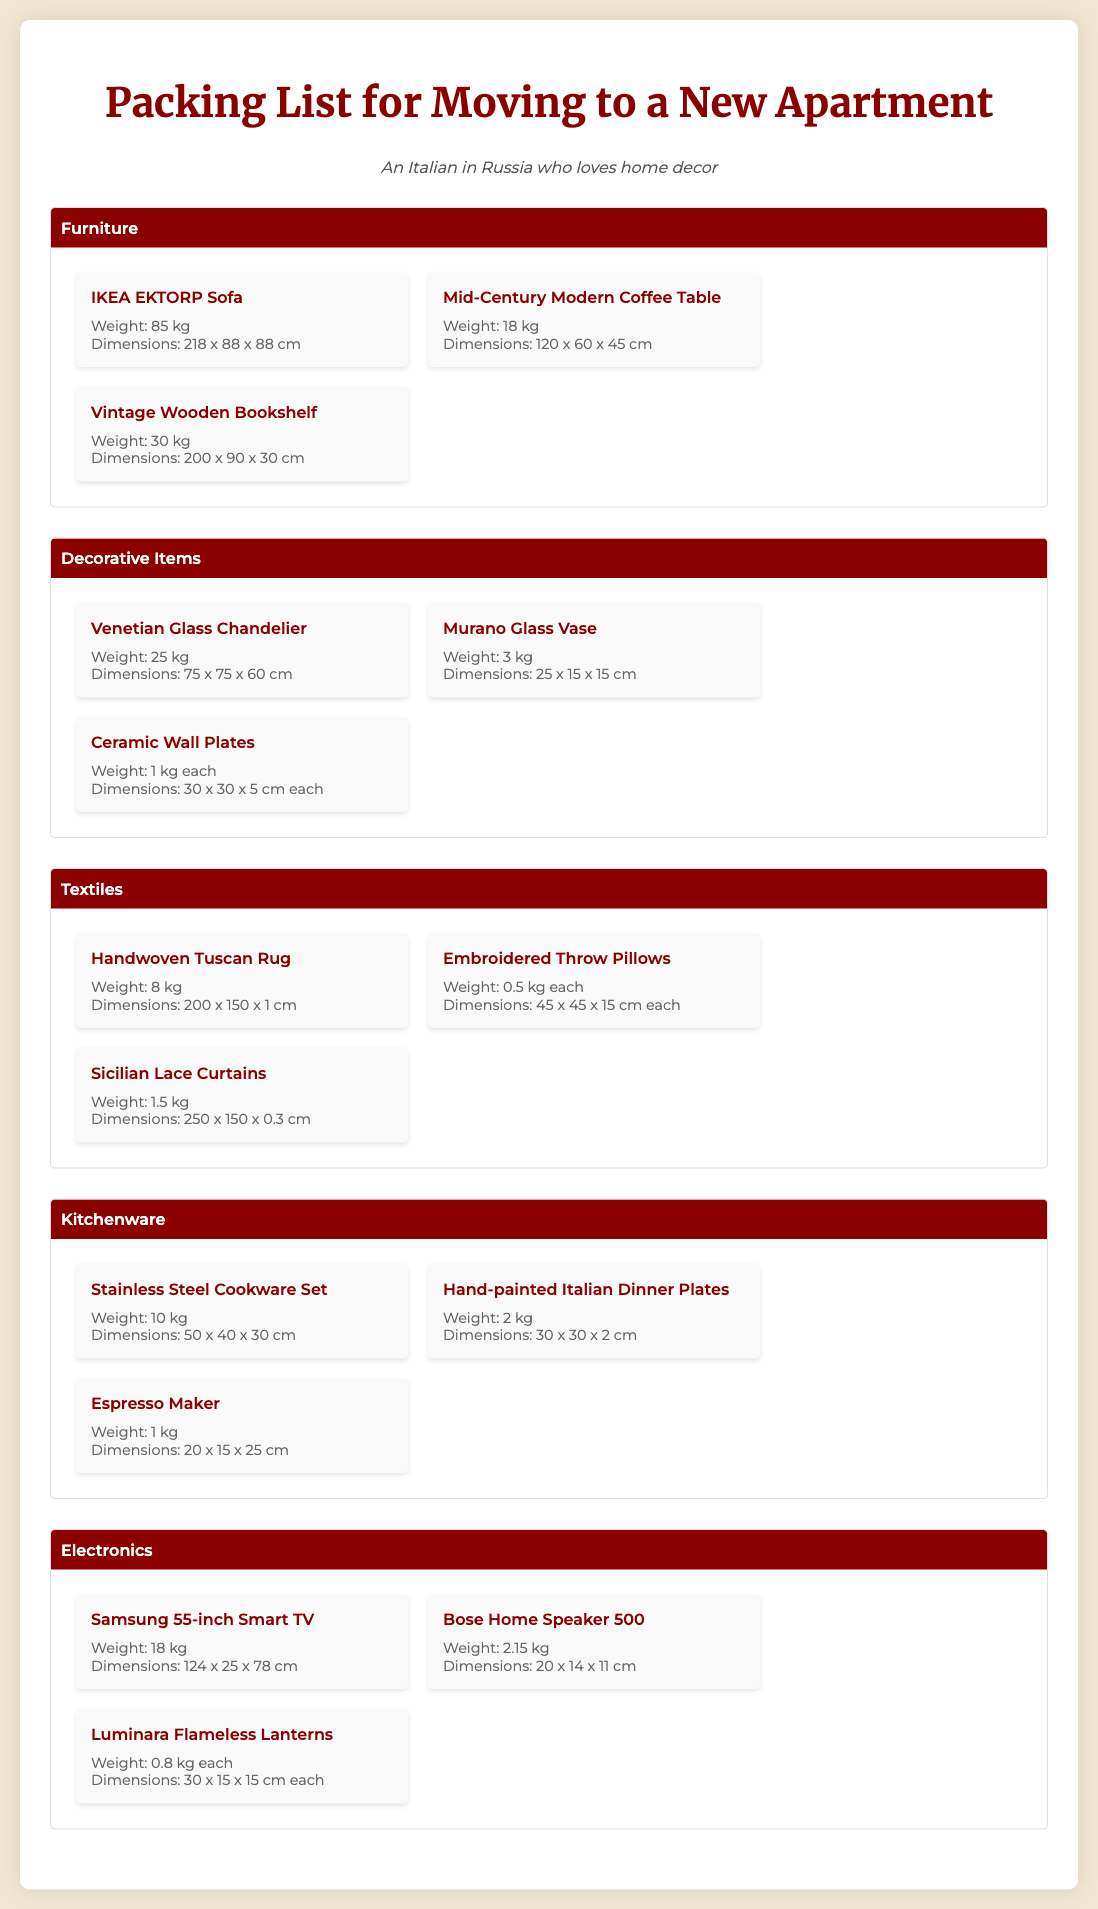What is the weight of the IKEA EKTORP Sofa? The weight of the IKEA EKTORP Sofa is specifically mentioned in the document as 85 kg.
Answer: 85 kg What are the dimensions of the Venetian Glass Chandelier? The dimensions of the Venetian Glass Chandelier are stated as 75 x 75 x 60 cm in the document.
Answer: 75 x 75 x 60 cm How many Decorative Items are listed? The document lists three items under Decorative Items: Venetian Glass Chandelier, Murano Glass Vase, and Ceramic Wall Plates.
Answer: Three Which furniture item has the highest weight? The item with the highest weight among the furniture listed is the IKEA EKTORP Sofa with a weight of 85 kg.
Answer: IKEA EKTORP Sofa What is the combined weight of the Textile items? The total weight of Textile items can be calculated as 8 kg (rug) + 0.5 kg (each pillow, two pillows) + 1.5 kg (curtains) = 10.5 kg.
Answer: 10.5 kg What type of cookware is included in the Kitchenware category? The Kitchenware category includes a Stainless Steel Cookware Set.
Answer: Stainless Steel Cookware Set Which type of curtains is in the packing list? The item listed for curtains in the packing list is Sicilian Lace Curtains.
Answer: Sicilian Lace Curtains What is the weight of each Ceramic Wall Plate? The document specifies that each Ceramic Wall Plate weighs 1 kg.
Answer: 1 kg How many throw pillows are mentioned? The document mentions embroidered throw pillows, but does not specify a number; instead, it states the weight for each.
Answer: Not specified 